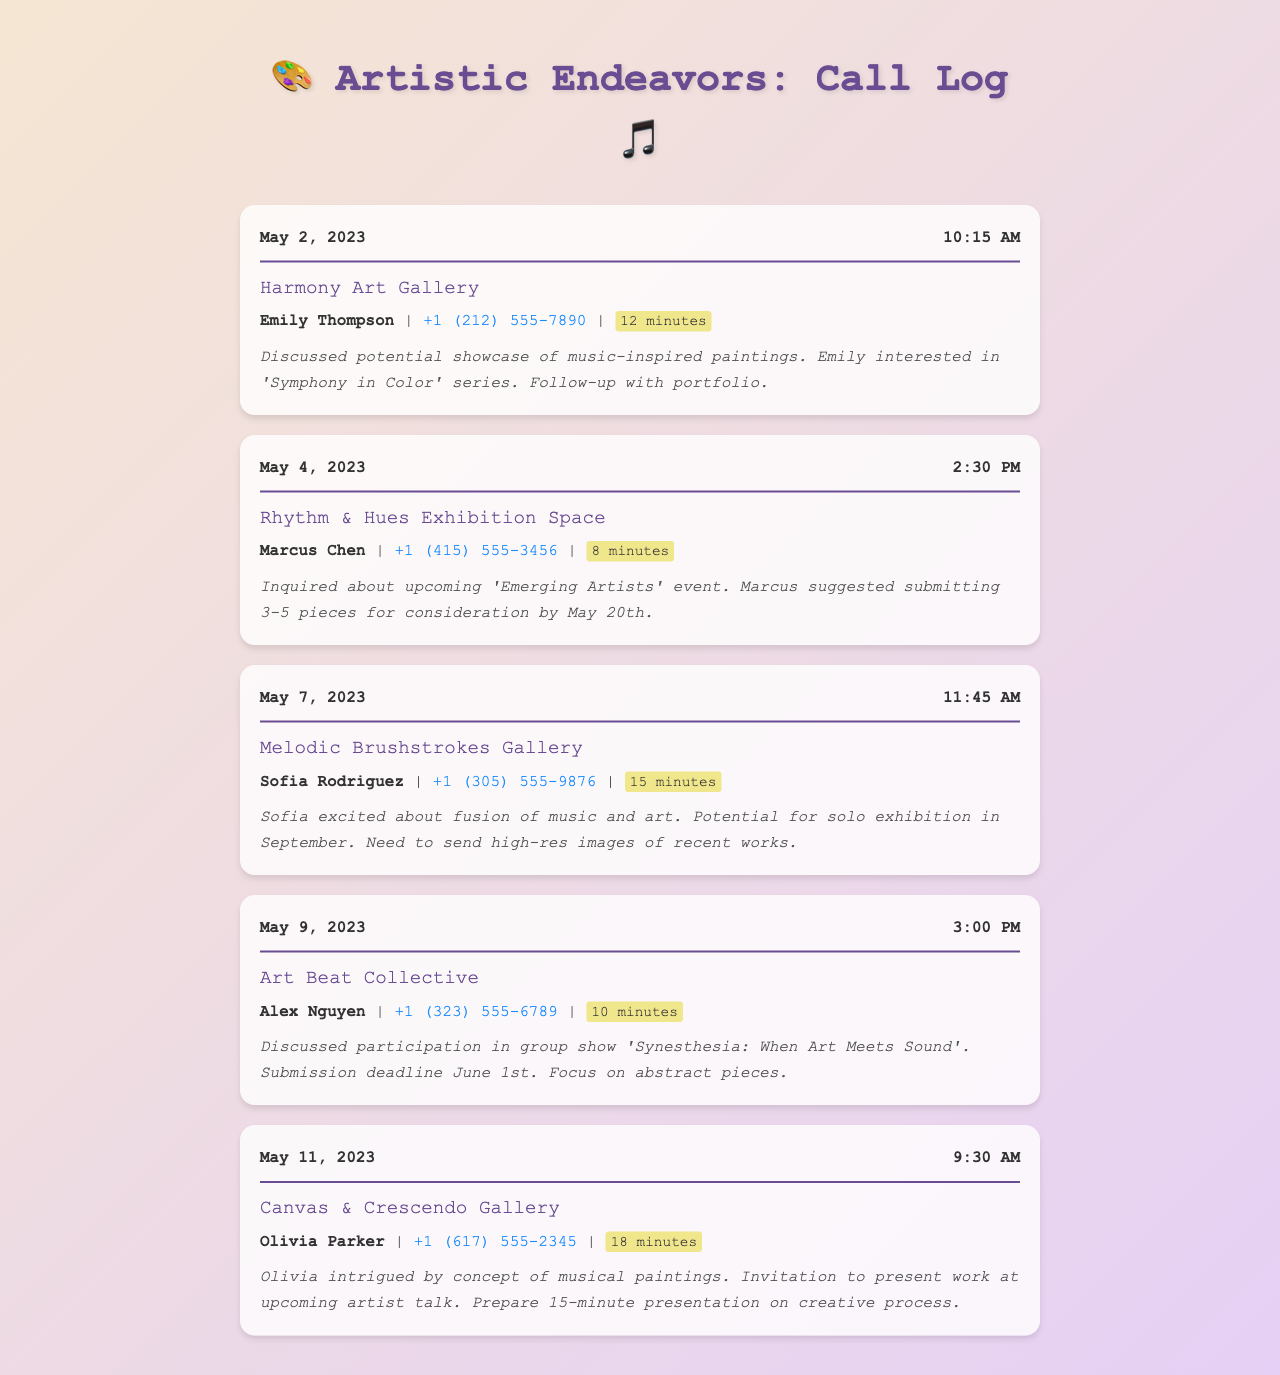what is the name of the first gallery called? The first gallery listed in the call log is Harmony Art Gallery.
Answer: Harmony Art Gallery who did you speak to at Melodic Brushstrokes Gallery? The contact person for Melodic Brushstrokes Gallery is Sofia Rodriguez.
Answer: Sofia Rodriguez how long was the call with Canvas & Crescendo Gallery? The duration of the call with Canvas & Crescendo Gallery was 18 minutes.
Answer: 18 minutes on what date was the call to Rhythm & Hues Exhibition Space made? The call to Rhythm & Hues Exhibition Space was made on May 4, 2023.
Answer: May 4, 2023 what is the submission deadline for the group show at Art Beat Collective? The submission deadline for the group show at Art Beat Collective is June 1st.
Answer: June 1st what was discussed during the call with Olivia Parker? During the call with Olivia Parker, the concept of musical paintings was discussed.
Answer: Concept of musical paintings which gallery was interested in the 'Symphony in Color' series? Harmony Art Gallery showed interest in the 'Symphony in Color' series.
Answer: Harmony Art Gallery how many pieces should be submitted for the 'Emerging Artists' event? Marcus suggested submitting 3-5 pieces for the event.
Answer: 3-5 pieces what type of exhibition is planned at Melodic Brushstrokes Gallery? A solo exhibition is planned at Melodic Brushstrokes Gallery.
Answer: Solo exhibition 